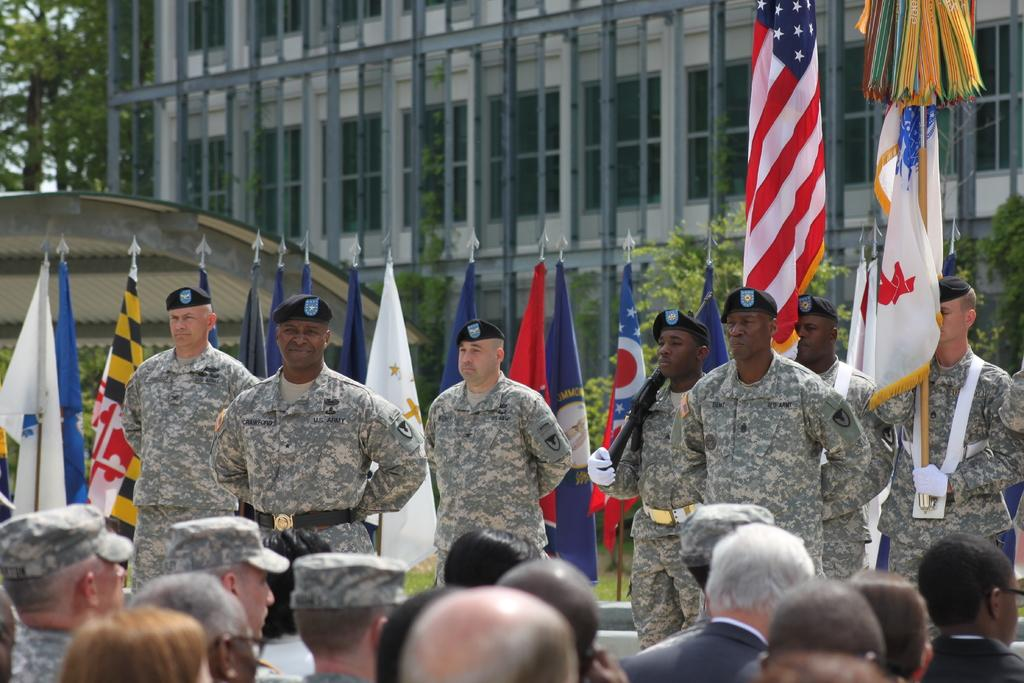What are the people in the image wearing? The people in the image are wearing army dresses. What else can be seen in the image besides the people? There are flags, trees, buildings, and windows in the image. What type of veil is draped over the table in the image? There is no table or veil present in the image. How many pizzas are visible on the windows in the image? There are no pizzas visible in the image, and they are not present on the windows. 